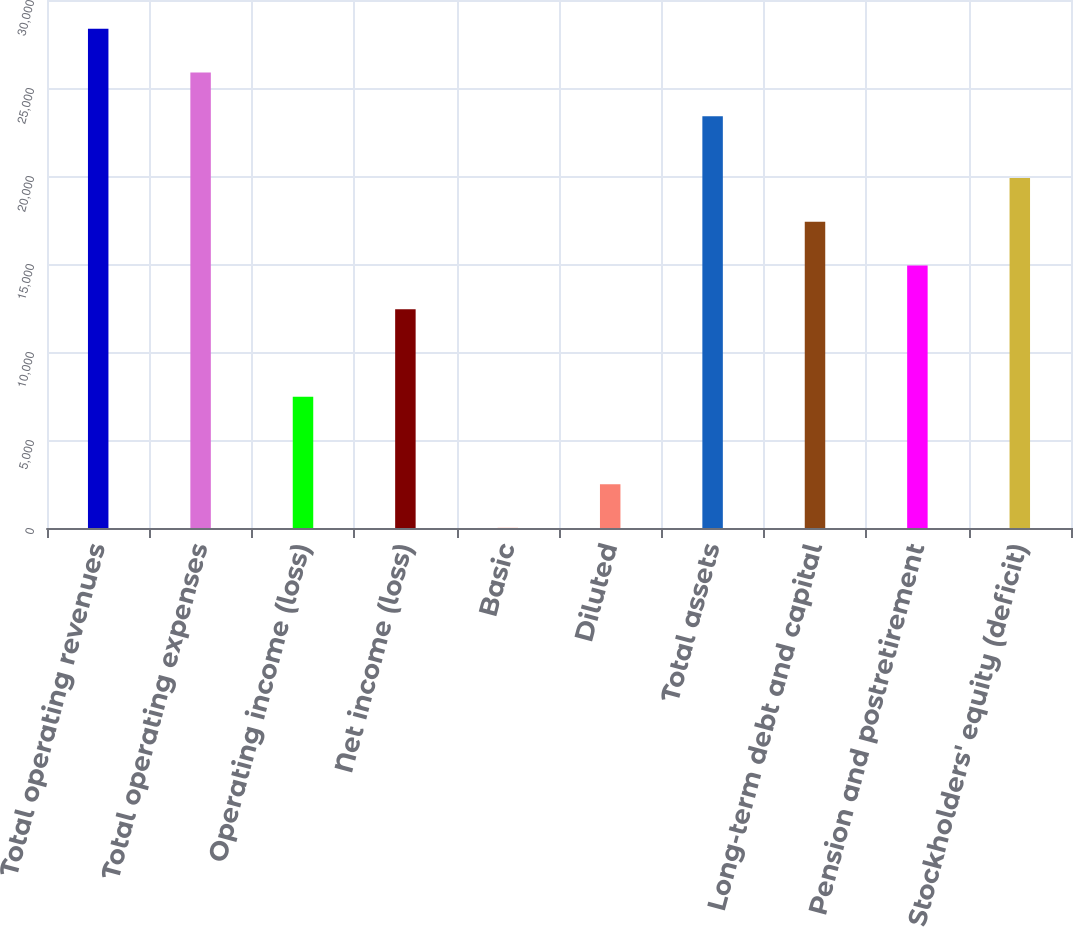Convert chart to OTSL. <chart><loc_0><loc_0><loc_500><loc_500><bar_chart><fcel>Total operating revenues<fcel>Total operating expenses<fcel>Operating income (loss)<fcel>Net income (loss)<fcel>Basic<fcel>Diluted<fcel>Total assets<fcel>Long-term debt and capital<fcel>Pension and postretirement<fcel>Stockholders' equity (deficit)<nl><fcel>28365.5<fcel>25880.8<fcel>7461.77<fcel>12431.3<fcel>7.52<fcel>2492.27<fcel>23396<fcel>17400.8<fcel>14916<fcel>19885.5<nl></chart> 